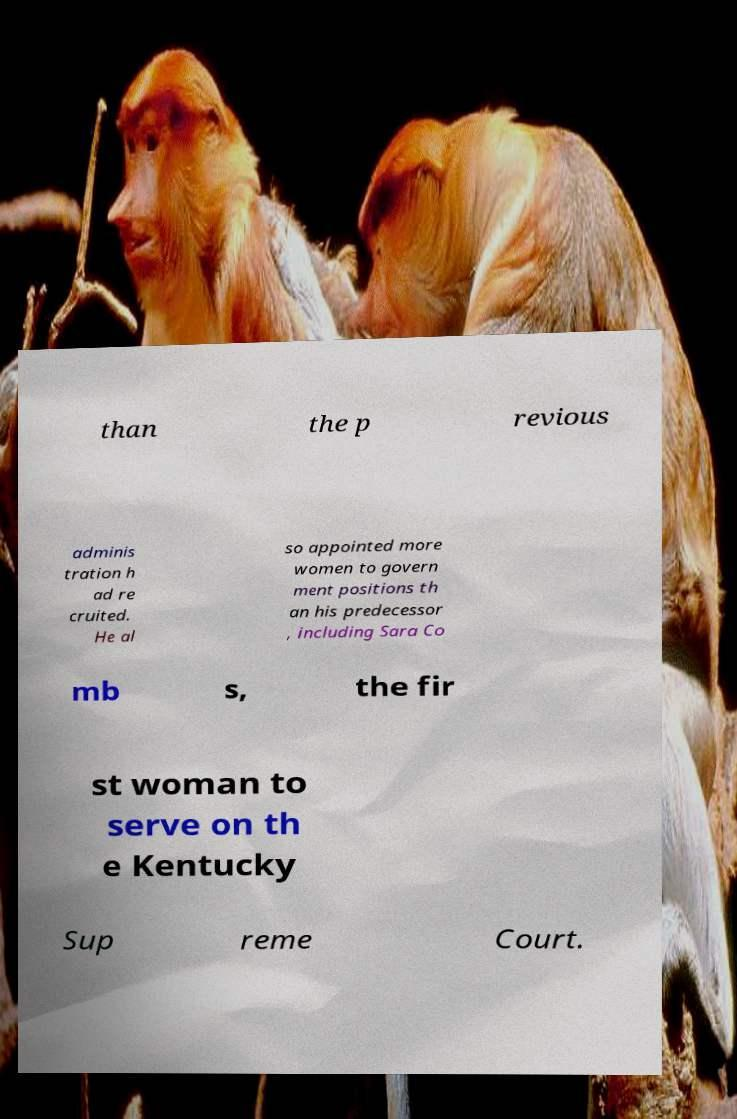Can you read and provide the text displayed in the image?This photo seems to have some interesting text. Can you extract and type it out for me? than the p revious adminis tration h ad re cruited. He al so appointed more women to govern ment positions th an his predecessor , including Sara Co mb s, the fir st woman to serve on th e Kentucky Sup reme Court. 